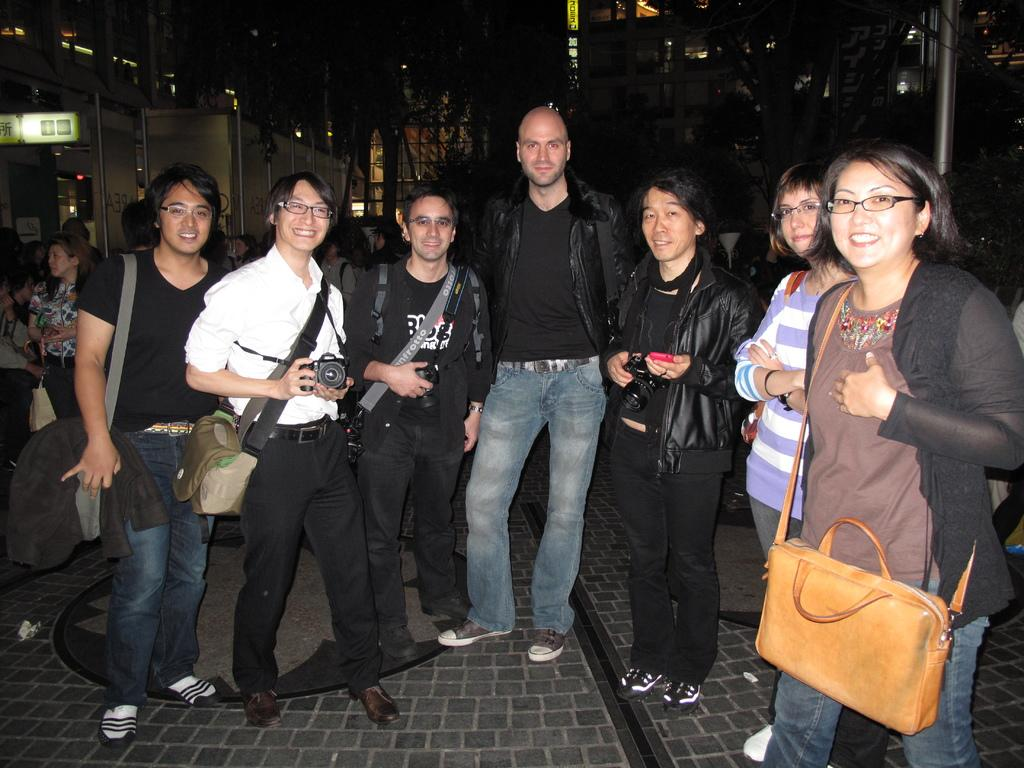What are the people in the image doing? The people in the image are standing with smiles on their faces. Can you describe the mood or emotion conveyed by the people in the image? The smiles on their faces suggest a happy or positive mood. Who is holding a camera in the image? There is a person holding a camera in the image. What type of scarf is being used to divide the people in the image? There is no scarf present in the image, nor is there any division among the people. 